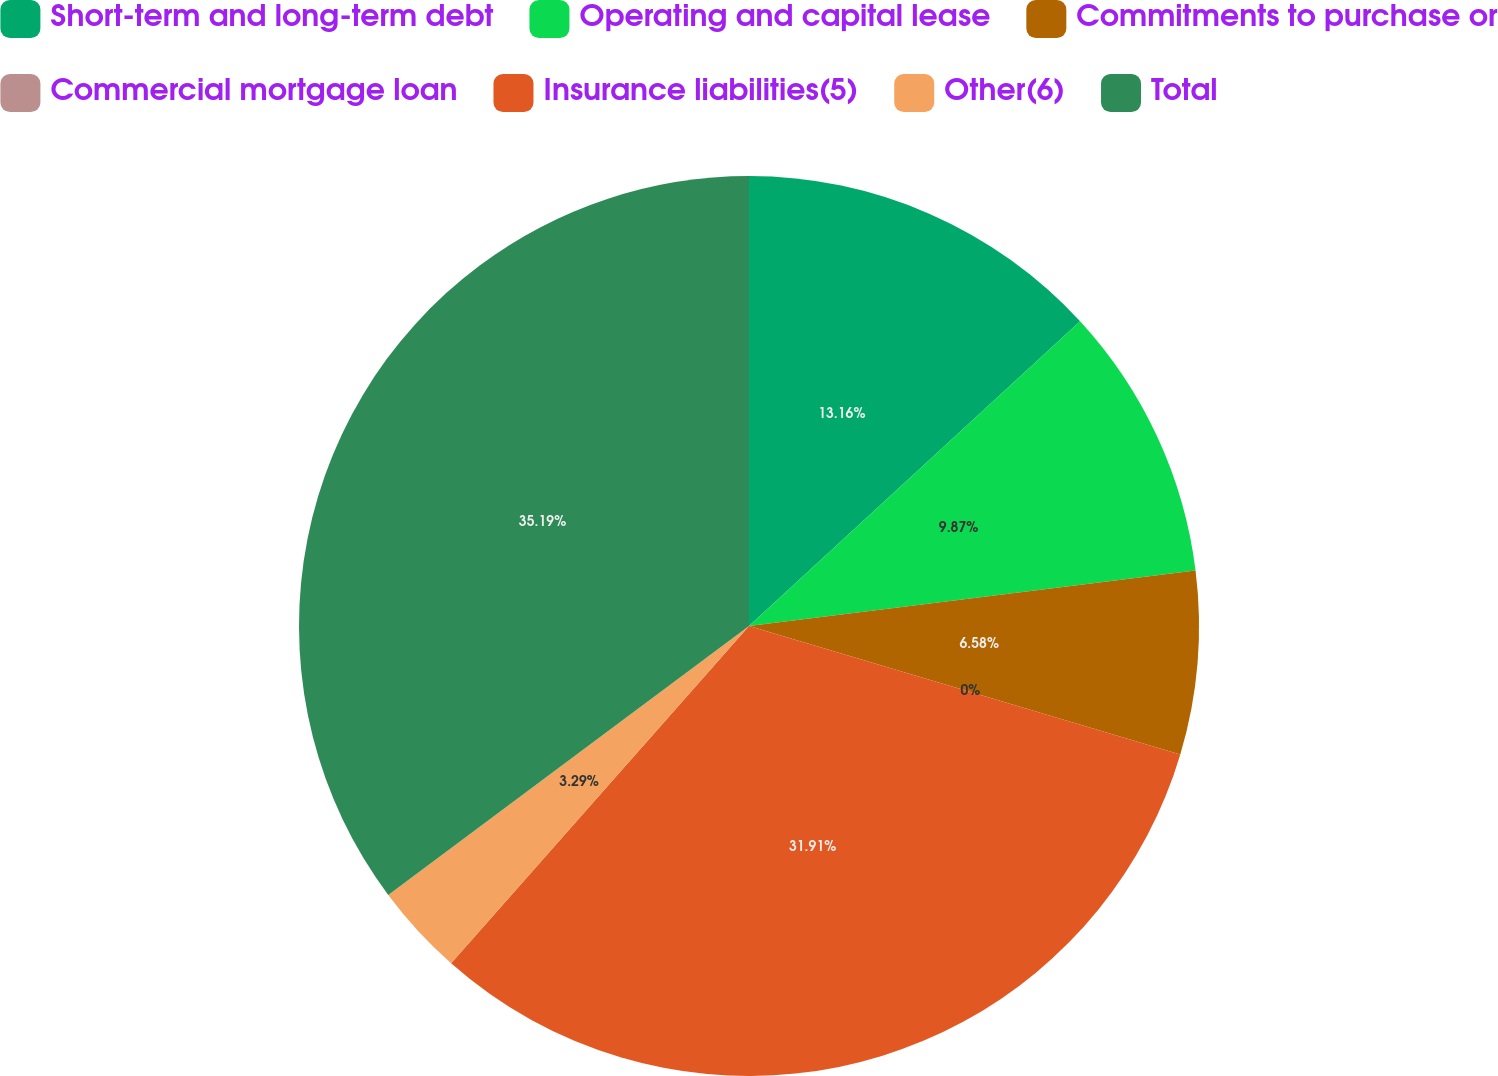<chart> <loc_0><loc_0><loc_500><loc_500><pie_chart><fcel>Short-term and long-term debt<fcel>Operating and capital lease<fcel>Commitments to purchase or<fcel>Commercial mortgage loan<fcel>Insurance liabilities(5)<fcel>Other(6)<fcel>Total<nl><fcel>13.16%<fcel>9.87%<fcel>6.58%<fcel>0.0%<fcel>31.91%<fcel>3.29%<fcel>35.2%<nl></chart> 